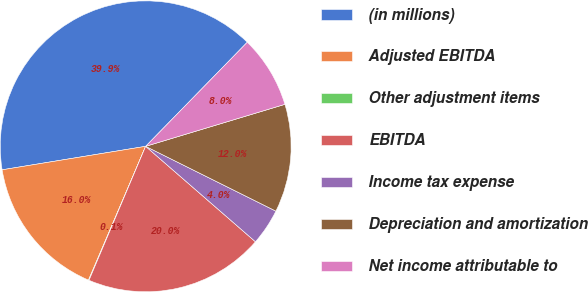<chart> <loc_0><loc_0><loc_500><loc_500><pie_chart><fcel>(in millions)<fcel>Adjusted EBITDA<fcel>Other adjustment items<fcel>EBITDA<fcel>Income tax expense<fcel>Depreciation and amortization<fcel>Net income attributable to<nl><fcel>39.89%<fcel>15.99%<fcel>0.06%<fcel>19.98%<fcel>4.04%<fcel>12.01%<fcel>8.03%<nl></chart> 